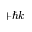<formula> <loc_0><loc_0><loc_500><loc_500>+ \hbar { k }</formula> 